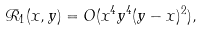<formula> <loc_0><loc_0><loc_500><loc_500>\mathcal { R } _ { 1 } ( x , y ) = O ( x ^ { 4 } y ^ { 4 } ( y - x ) ^ { 2 } ) ,</formula> 